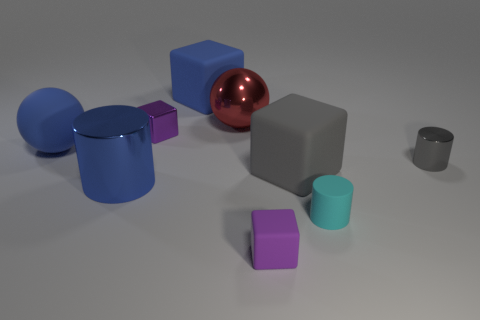How many other things are there of the same size as the blue cylinder?
Provide a succinct answer. 4. What shape is the thing that is the same color as the small metallic cube?
Offer a terse response. Cube. What size is the purple cube that is behind the tiny cylinder that is behind the small cyan matte object?
Keep it short and to the point. Small. How many spheres are either tiny blue metallic things or red objects?
Offer a very short reply. 1. What color is the metallic sphere that is the same size as the blue metallic object?
Offer a terse response. Red. What is the shape of the large blue object in front of the blue matte object in front of the purple shiny object?
Provide a succinct answer. Cylinder. Does the purple block behind the purple matte object have the same size as the red thing?
Your response must be concise. No. What number of other things are there of the same material as the big blue sphere
Your answer should be very brief. 4. How many purple things are either tiny metal cylinders or small shiny objects?
Keep it short and to the point. 1. What size is the cylinder that is the same color as the big matte ball?
Your answer should be compact. Large. 